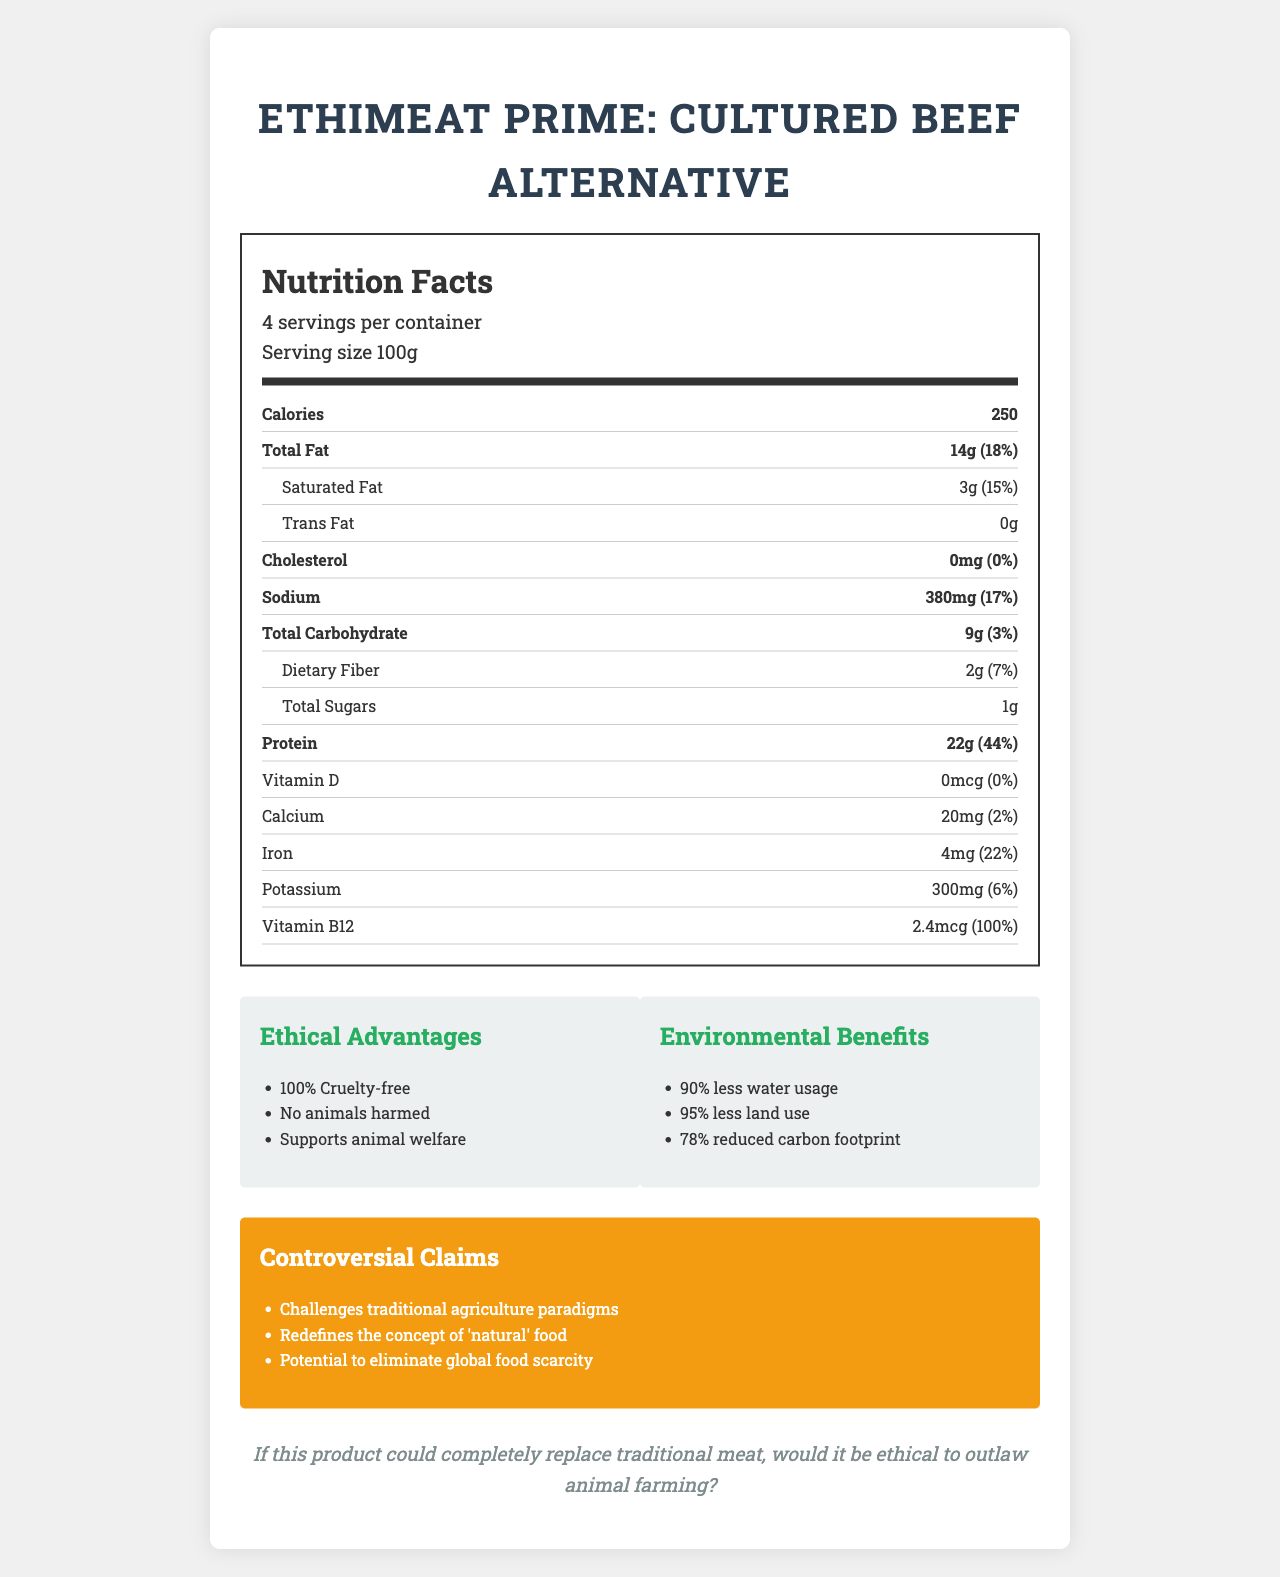what is the serving size? The document states that the serving size is 100g.
Answer: 100g how many servings are in one container? The document mentions that there are 4 servings per container.
Answer: 4 what is the total fat content per serving? The document lists the total fat content per serving as 14g.
Answer: 14g how much protein does each serving contain? According to the document, each serving contains 22g of protein.
Answer: 22g what are the three main ethical advantages mentioned? The three main ethical advantages listed in the document are 100% Cruelty-free, No animals harmed, and Supports animal welfare.
Answer: 1. 100% Cruelty-free 2. No animals harmed 3. Supports animal welfare which of the following is NOT listed as an ingredient in EthiMeat Prime? A. Cultured bovine cells B. Soy protein C. Beet juice concentrate D. Potato starch The document lists the ingredients and Soy protein is not one of them.
Answer: B. Soy protein what is the daily value percentage of saturated fat per serving? A. 10% B. 15% C. 18% D. 20% The document indicates that the daily value percentage of saturated fat per serving is 15%.
Answer: B. 15% is trans fat present in EthiMeat Prime? The document states that the trans fat content is 0g.
Answer: No what are the two main environmental benefits of EthiMeat Prime? The document lists 90% less water usage and 95% less land use as two of the main environmental benefits.
Answer: 1. 90% less water usage 2. 95% less land use summarize the main idea of the EthiMeat Prime Nutrition Label. The production method is cruelty-free and environmentally friendly, utilizing renewable energy sources and bioreactors. It is also certified as non-GMO, carbon-neutral, and approved by the Ethical Protein Alliance.
Answer: EthiMeat Prime: Cultured Beef Alternative is a synthetic meat product that provides nutritional benefits such as high protein and no cholesterol. It is designed to offer ethical advantages like 100% cruelty-free production and supports animal welfare, along with environmental benefits like reduced water and land usage. The product challenges traditional agricultural paradigms and is considered to redefine the concept of 'natural' food. what is the daily value percentage of vitamin B12 per serving? The document states that the daily value percentage of vitamin B12 per serving is 100%.
Answer: 100% does the product contain any allergens? The document specifies that the product contains no allergens but is produced in a facility that processes soy and wheat.
Answer: No what controversial claim does EthiMeat Prime make about global food scarcity? One of the controversial claims listed in the document is the potential to eliminate global food scarcity.
Answer: Potential to eliminate global food scarcity how should EthiMeat Prime be stored for long-term use? The document indicates that the product can be stored frozen for up to 6 months for long-term use.
Answer: Frozen, up to 6 months what is the total amount of carbohydrates per serving? The document lists the total carbohydrate content per serving as 9g.
Answer: 9g what is the water usage reduction percentage in the production of EthiMeat Prime compared to traditional meat? The document states that EthiMeat Prime uses 90% less water in its production compared to traditional meat.
Answer: 90% less water usage how many questions does the "thought experiment" ask in the document? The document presents one thought experiment question: "If this product could completely replace traditional meat, would it be ethical to outlaw animal farming?"
Answer: 1 what other animal-derived ingredients are there in EthiMeat Prime besides cultured bovine cells? The document does not provide information on whether other animal-derived ingredients are present besides cultured bovine cells.
Answer: Cannot be determined 